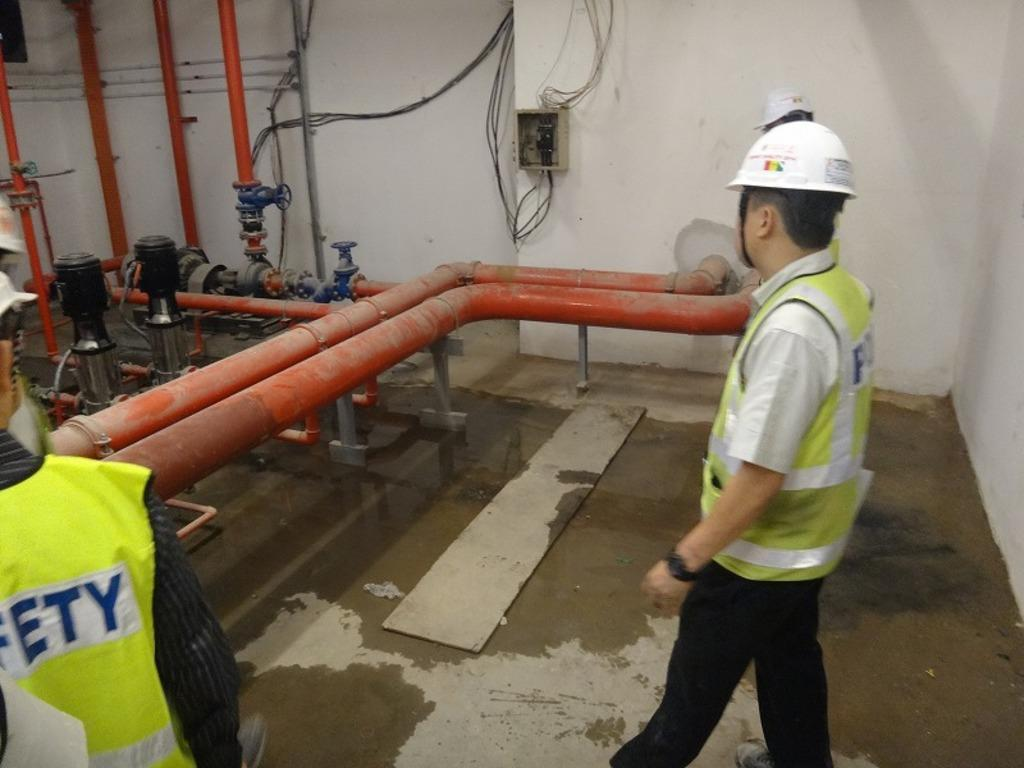How many people are in the group shown in the image? There is a group of people in the image, but the exact number is not specified. What are some people in the group wearing? Some people in the group are wearing helmets. What can be seen in the background of the image? There is water visible in the image, as well as a box on the wall. What type of equipment is present in the image? There are pipes, machines, and helmets visible in the image. What type of fiction is being read by the people in the image? There is no indication in the image that the people are reading any fiction. Can you tell me how much juice is being consumed by the group in the image? There is no juice present in the image, so it cannot be determined how much is being consumed. 